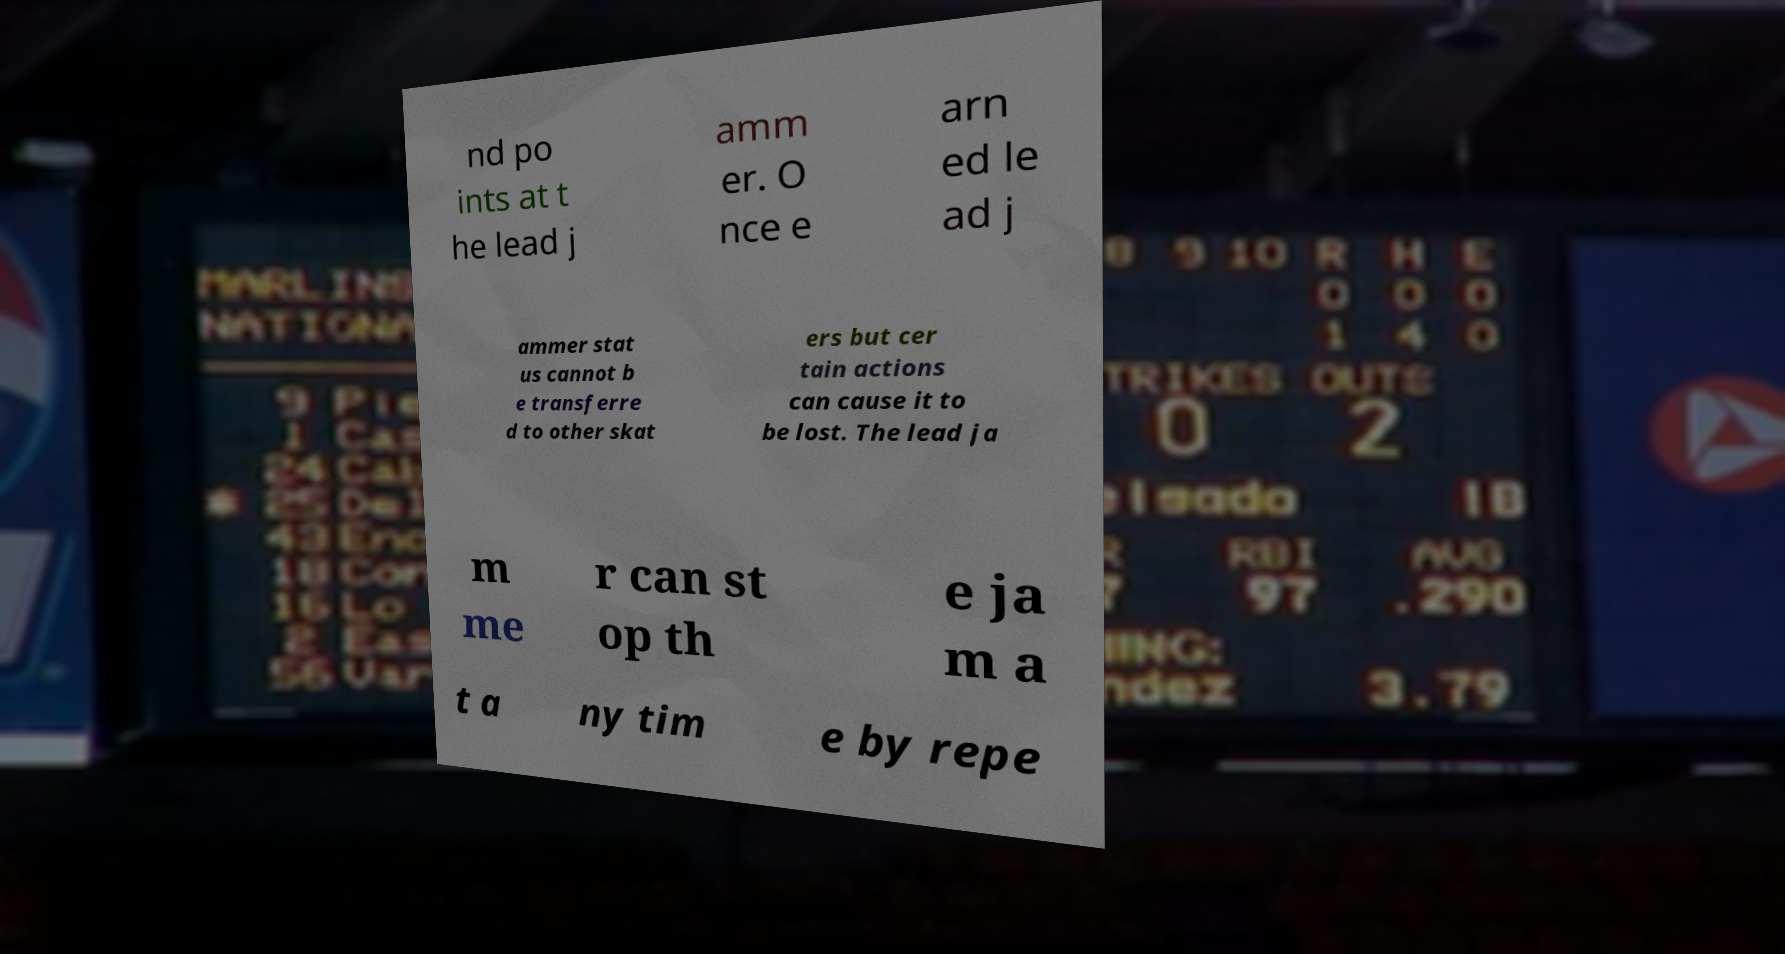I need the written content from this picture converted into text. Can you do that? nd po ints at t he lead j amm er. O nce e arn ed le ad j ammer stat us cannot b e transferre d to other skat ers but cer tain actions can cause it to be lost. The lead ja m me r can st op th e ja m a t a ny tim e by repe 